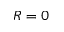<formula> <loc_0><loc_0><loc_500><loc_500>R = 0</formula> 